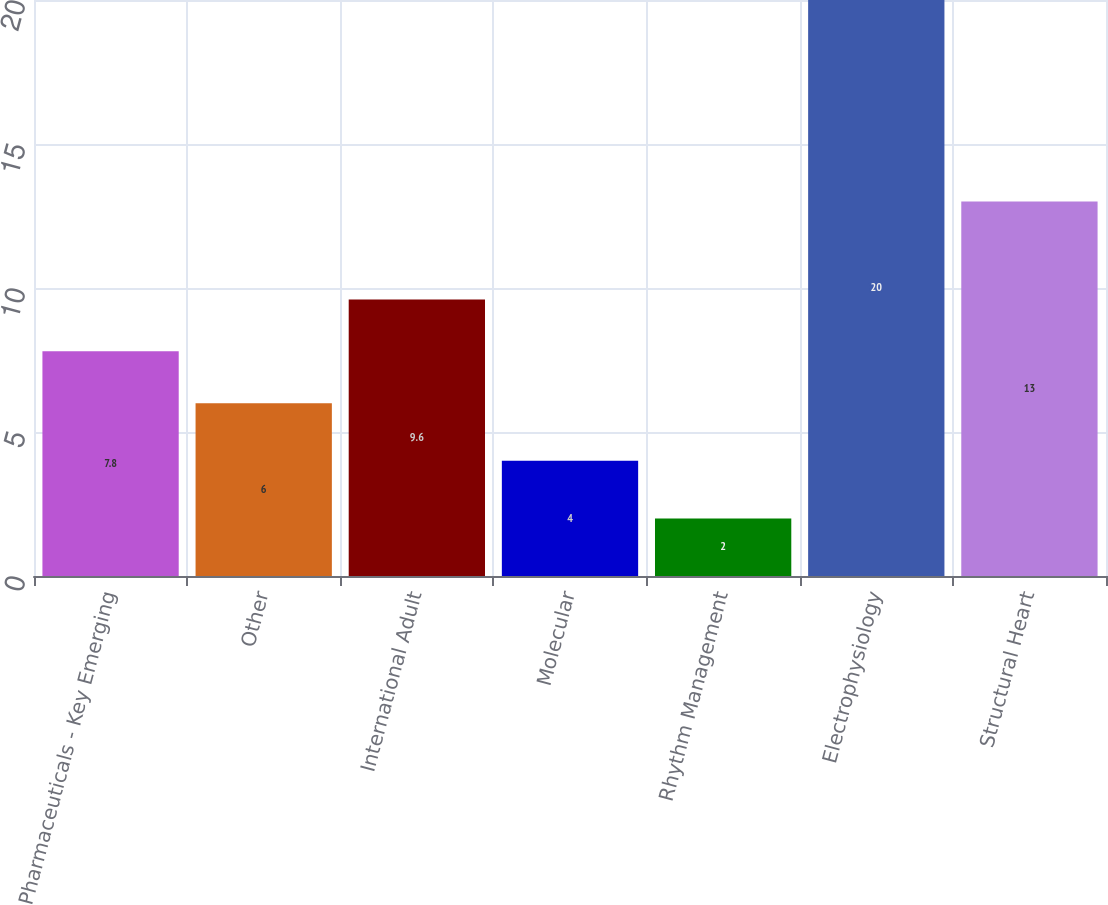Convert chart to OTSL. <chart><loc_0><loc_0><loc_500><loc_500><bar_chart><fcel>Pharmaceuticals - Key Emerging<fcel>Other<fcel>International Adult<fcel>Molecular<fcel>Rhythm Management<fcel>Electrophysiology<fcel>Structural Heart<nl><fcel>7.8<fcel>6<fcel>9.6<fcel>4<fcel>2<fcel>20<fcel>13<nl></chart> 